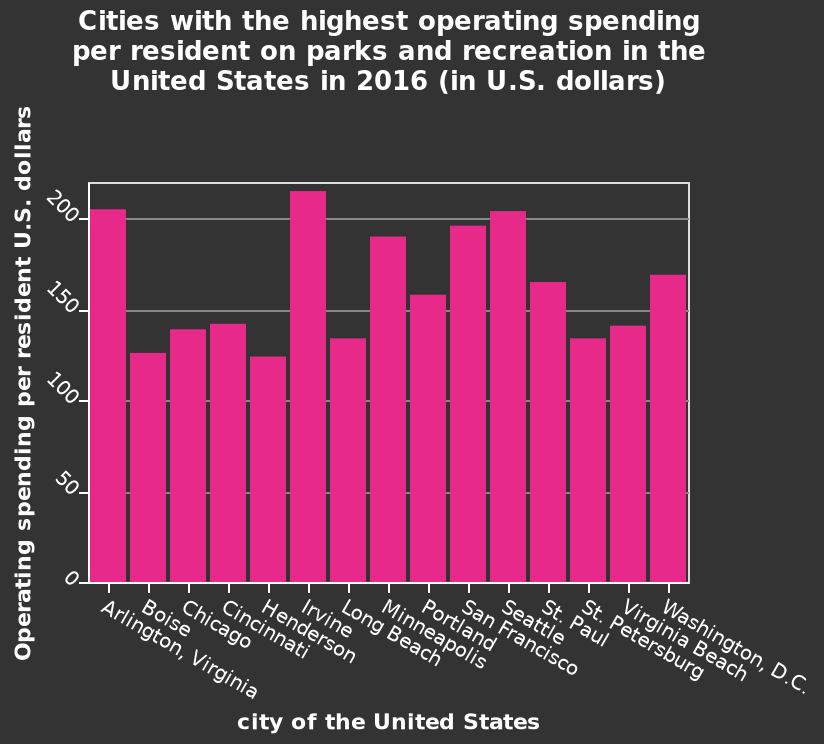<image>
please summary the statistics and relations of the chart steady spending all round in all states/cities - not drastic lows or highs. 